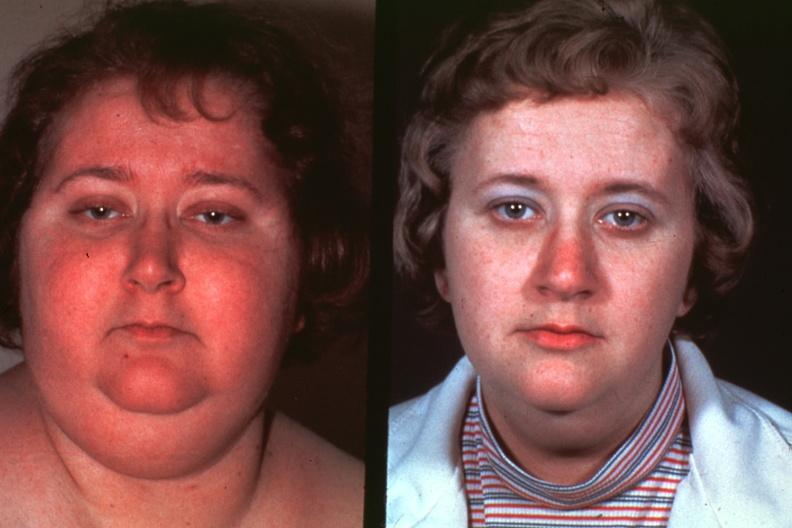what is present?
Answer the question using a single word or phrase. Cushings disease 